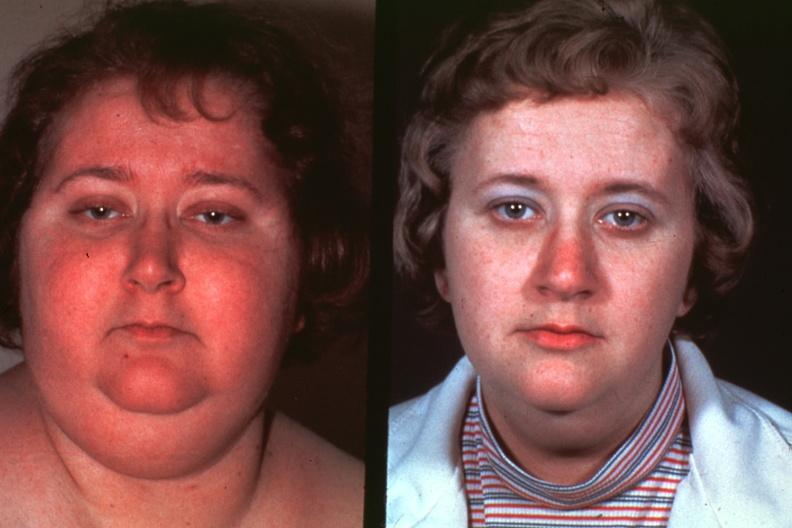what is present?
Answer the question using a single word or phrase. Cushings disease 